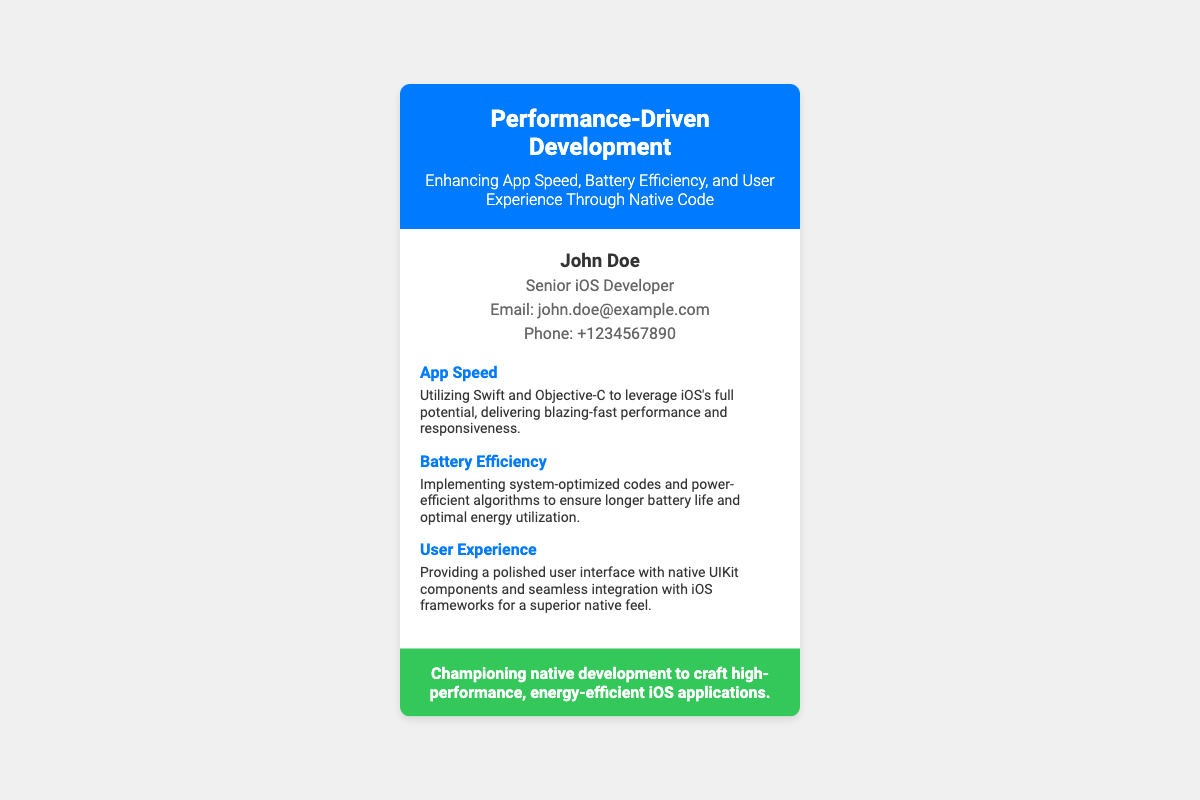What is the name of the developer? The name of the developer is provided in the personal info section.
Answer: John Doe What is the email address listed? The email address is found in the personal info section.
Answer: john.doe@example.com What is the phone number provided? The phone number can be found in the personal info section of the document.
Answer: +1234567890 What programming languages does the developer utilize? The document mentions the specific languages under the App Speed section.
Answer: Swift and Objective-C What is emphasized for improving battery life? This information is detailed under the Battery Efficiency key point.
Answer: Power-efficient algorithms Which title is given to the developer? The title is found in the personal info section.
Answer: Senior iOS Developer What color is used in the header? The header color can be found by visual analysis of the header section.
Answer: Blue What is the main focus of the development approach? This answer summarizes the content in the header of the document.
Answer: Native code What area of user experience is highlighted? The specific aspect is mentioned in the User Experience key point.
Answer: Polished user interface 